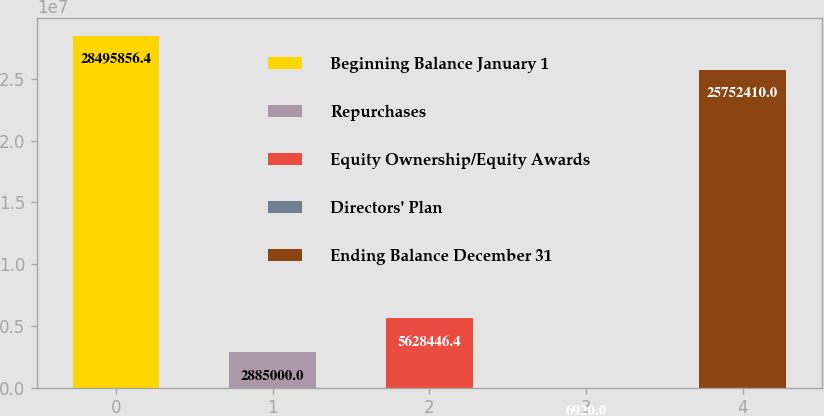Convert chart. <chart><loc_0><loc_0><loc_500><loc_500><bar_chart><fcel>Beginning Balance January 1<fcel>Repurchases<fcel>Equity Ownership/Equity Awards<fcel>Directors' Plan<fcel>Ending Balance December 31<nl><fcel>2.84959e+07<fcel>2.885e+06<fcel>5.62845e+06<fcel>6920<fcel>2.57524e+07<nl></chart> 